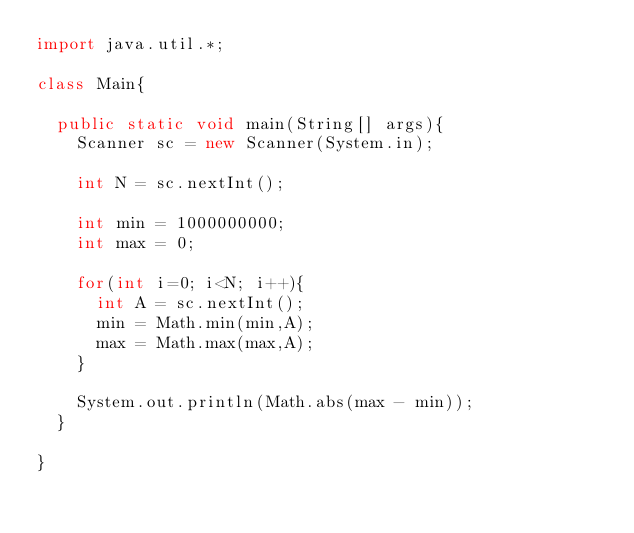Convert code to text. <code><loc_0><loc_0><loc_500><loc_500><_Java_>import java.util.*;

class Main{

	public static void main(String[] args){
		Scanner sc = new Scanner(System.in);
		
		int N = sc.nextInt();

		int min = 1000000000;
		int max = 0;

		for(int i=0; i<N; i++){
			int A = sc.nextInt();
			min = Math.min(min,A);
			max = Math.max(max,A);
		}

		System.out.println(Math.abs(max - min));
	}

}
</code> 